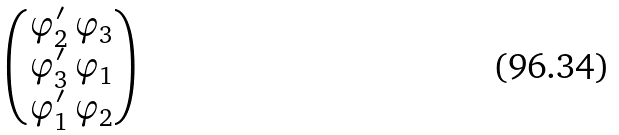<formula> <loc_0><loc_0><loc_500><loc_500>\begin{pmatrix} \varphi _ { 2 } ^ { \prime } \, \varphi _ { 3 } \\ \varphi _ { 3 } ^ { \prime } \, \varphi _ { 1 } \\ \varphi _ { 1 } ^ { \prime } \, \varphi _ { 2 } \end{pmatrix}</formula> 